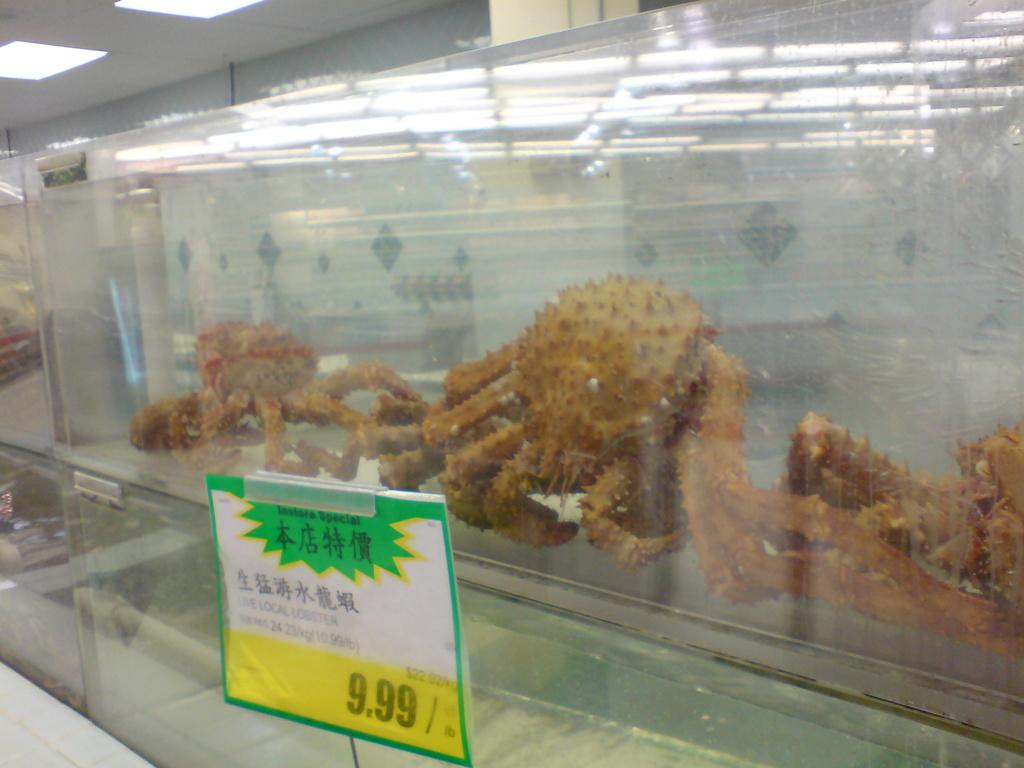What object in the image has a price label on it? The glass in the image has a price label on it. What is inside the glass? There is food in the glass. What can be seen above the objects in the image? The ceiling is visible in the image. What is present on the ceiling? There are lights on the ceiling. Can you hear the sound of thunder in the image? There is no sound present in the image, and therefore no thunder can be heard. 